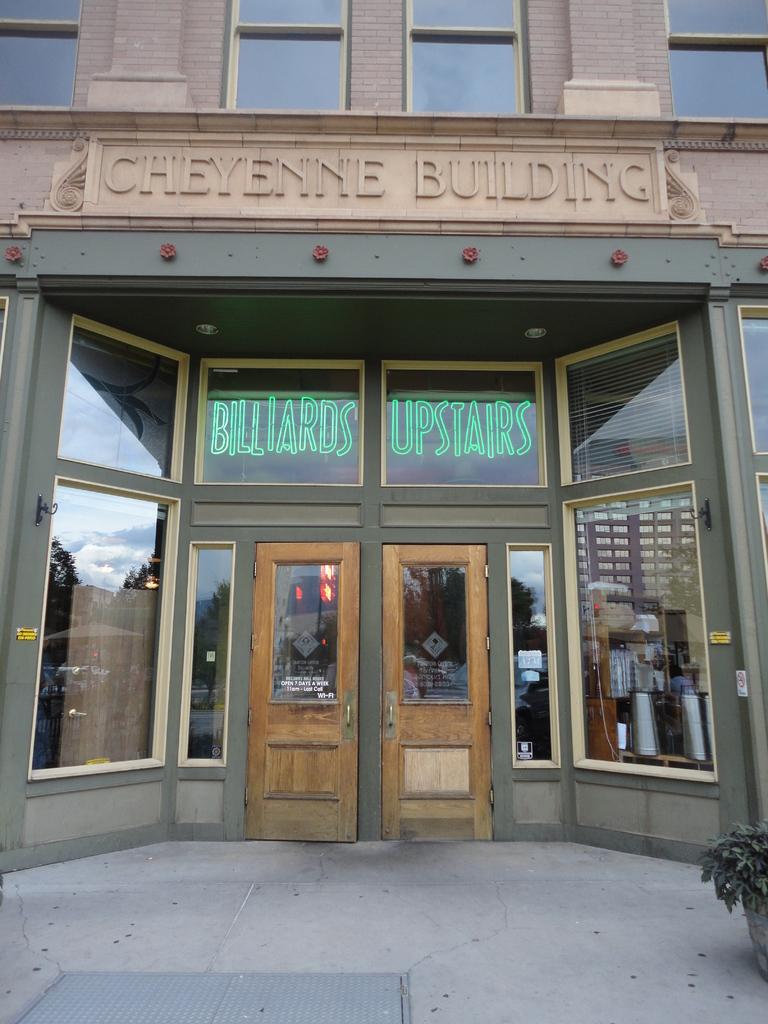Can you describe this image briefly? This is a picture of a building with doors and some text written on it, in front of the building there is a flower pot. 